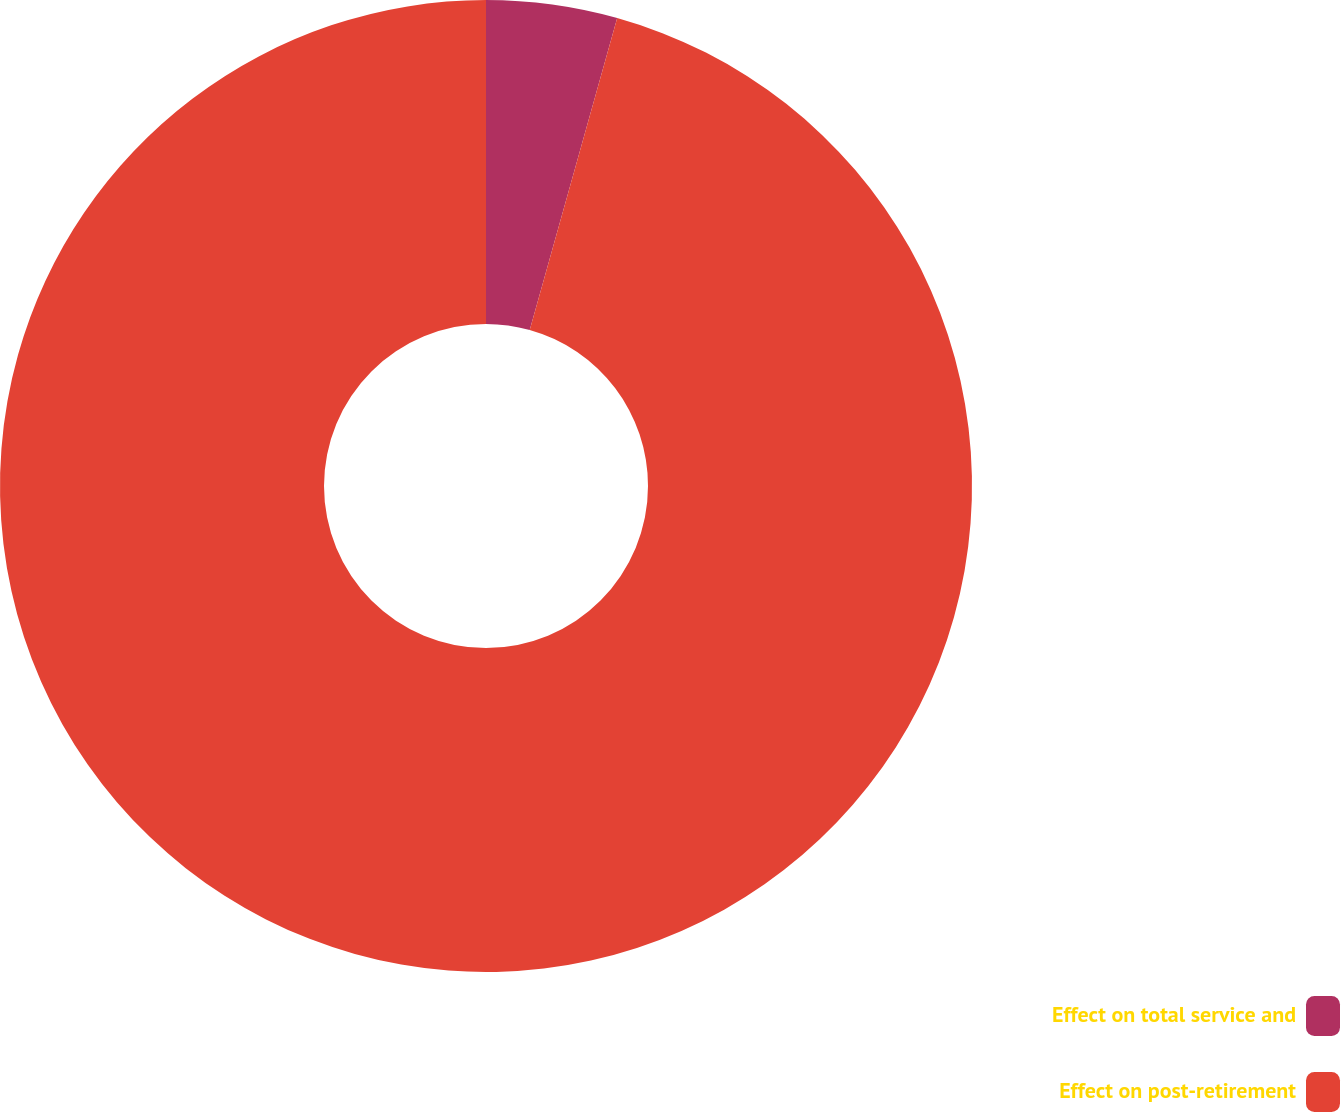<chart> <loc_0><loc_0><loc_500><loc_500><pie_chart><fcel>Effect on total service and<fcel>Effect on post-retirement<nl><fcel>4.35%<fcel>95.65%<nl></chart> 